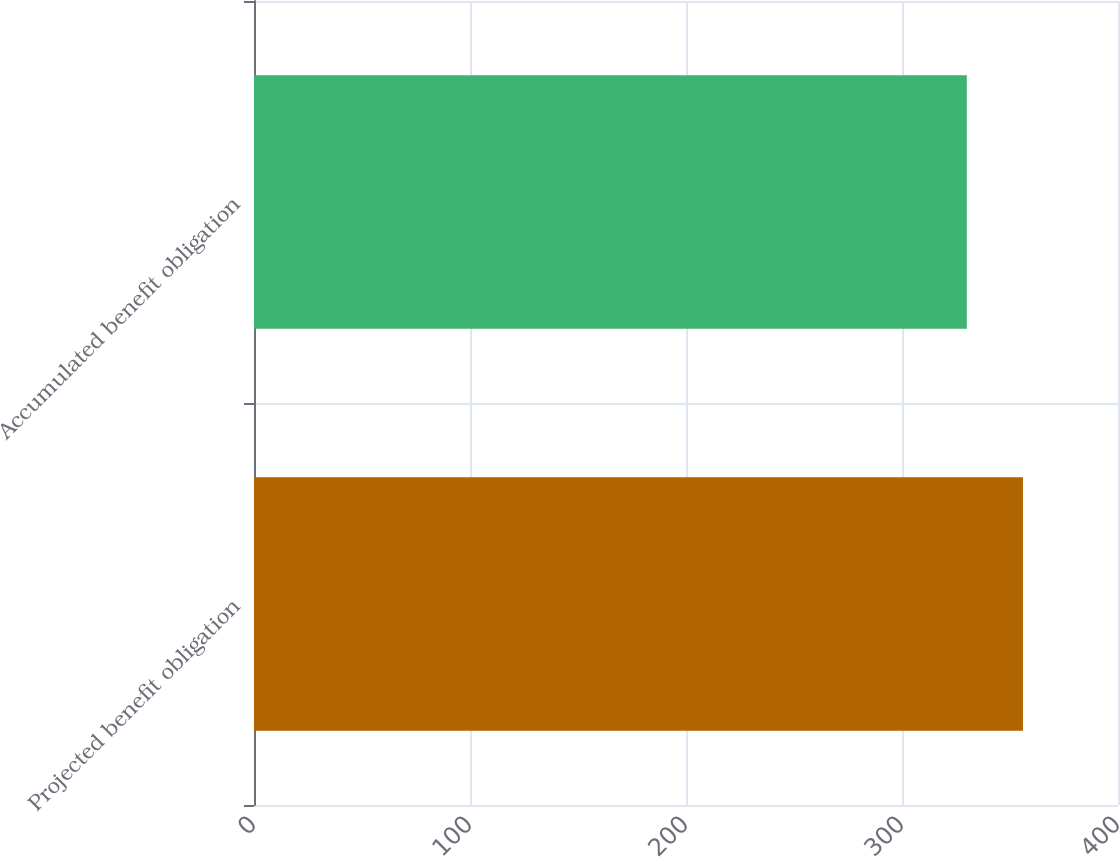<chart> <loc_0><loc_0><loc_500><loc_500><bar_chart><fcel>Projected benefit obligation<fcel>Accumulated benefit obligation<nl><fcel>356<fcel>330<nl></chart> 